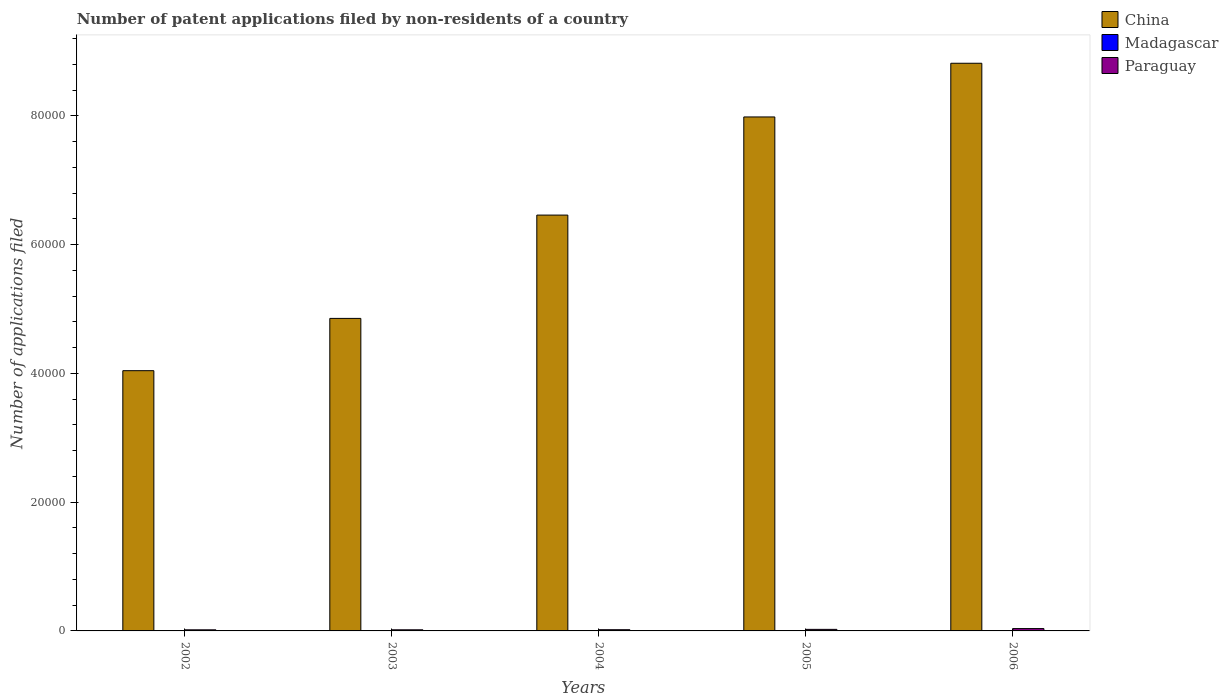How many different coloured bars are there?
Keep it short and to the point. 3. How many groups of bars are there?
Your answer should be compact. 5. Are the number of bars on each tick of the X-axis equal?
Your answer should be very brief. Yes. What is the number of applications filed in Madagascar in 2004?
Give a very brief answer. 22. Across all years, what is the minimum number of applications filed in Madagascar?
Provide a short and direct response. 20. What is the total number of applications filed in China in the graph?
Provide a succinct answer. 3.22e+05. What is the difference between the number of applications filed in Paraguay in 2002 and that in 2006?
Make the answer very short. -193. What is the difference between the number of applications filed in China in 2005 and the number of applications filed in Madagascar in 2006?
Your answer should be compact. 7.98e+04. What is the average number of applications filed in China per year?
Your response must be concise. 6.43e+04. In the year 2004, what is the difference between the number of applications filed in China and number of applications filed in Madagascar?
Provide a succinct answer. 6.46e+04. What is the ratio of the number of applications filed in Madagascar in 2003 to that in 2005?
Offer a very short reply. 0.57. Is the difference between the number of applications filed in China in 2002 and 2005 greater than the difference between the number of applications filed in Madagascar in 2002 and 2005?
Your answer should be very brief. No. What is the difference between the highest and the second highest number of applications filed in Paraguay?
Your answer should be compact. 123. What is the difference between the highest and the lowest number of applications filed in Paraguay?
Keep it short and to the point. 193. In how many years, is the number of applications filed in China greater than the average number of applications filed in China taken over all years?
Ensure brevity in your answer.  3. What does the 3rd bar from the left in 2005 represents?
Offer a very short reply. Paraguay. What does the 1st bar from the right in 2005 represents?
Offer a terse response. Paraguay. Is it the case that in every year, the sum of the number of applications filed in Paraguay and number of applications filed in China is greater than the number of applications filed in Madagascar?
Your response must be concise. Yes. How many bars are there?
Ensure brevity in your answer.  15. Does the graph contain any zero values?
Ensure brevity in your answer.  No. Where does the legend appear in the graph?
Ensure brevity in your answer.  Top right. How many legend labels are there?
Give a very brief answer. 3. What is the title of the graph?
Your answer should be very brief. Number of patent applications filed by non-residents of a country. Does "High income: OECD" appear as one of the legend labels in the graph?
Provide a succinct answer. No. What is the label or title of the X-axis?
Ensure brevity in your answer.  Years. What is the label or title of the Y-axis?
Keep it short and to the point. Number of applications filed. What is the Number of applications filed in China in 2002?
Give a very brief answer. 4.04e+04. What is the Number of applications filed of Madagascar in 2002?
Provide a succinct answer. 25. What is the Number of applications filed of Paraguay in 2002?
Keep it short and to the point. 171. What is the Number of applications filed of China in 2003?
Offer a very short reply. 4.85e+04. What is the Number of applications filed of Paraguay in 2003?
Your answer should be compact. 173. What is the Number of applications filed in China in 2004?
Your answer should be very brief. 6.46e+04. What is the Number of applications filed of Madagascar in 2004?
Offer a terse response. 22. What is the Number of applications filed of Paraguay in 2004?
Ensure brevity in your answer.  187. What is the Number of applications filed of China in 2005?
Offer a terse response. 7.98e+04. What is the Number of applications filed of Madagascar in 2005?
Your answer should be compact. 35. What is the Number of applications filed in Paraguay in 2005?
Provide a succinct answer. 241. What is the Number of applications filed in China in 2006?
Provide a succinct answer. 8.82e+04. What is the Number of applications filed in Madagascar in 2006?
Your response must be concise. 40. What is the Number of applications filed in Paraguay in 2006?
Make the answer very short. 364. Across all years, what is the maximum Number of applications filed in China?
Give a very brief answer. 8.82e+04. Across all years, what is the maximum Number of applications filed of Madagascar?
Your answer should be very brief. 40. Across all years, what is the maximum Number of applications filed in Paraguay?
Ensure brevity in your answer.  364. Across all years, what is the minimum Number of applications filed in China?
Offer a very short reply. 4.04e+04. Across all years, what is the minimum Number of applications filed in Paraguay?
Offer a very short reply. 171. What is the total Number of applications filed of China in the graph?
Keep it short and to the point. 3.22e+05. What is the total Number of applications filed of Madagascar in the graph?
Your answer should be very brief. 142. What is the total Number of applications filed in Paraguay in the graph?
Offer a terse response. 1136. What is the difference between the Number of applications filed of China in 2002 and that in 2003?
Your answer should be compact. -8122. What is the difference between the Number of applications filed in China in 2002 and that in 2004?
Give a very brief answer. -2.42e+04. What is the difference between the Number of applications filed of China in 2002 and that in 2005?
Offer a terse response. -3.94e+04. What is the difference between the Number of applications filed in Paraguay in 2002 and that in 2005?
Provide a succinct answer. -70. What is the difference between the Number of applications filed in China in 2002 and that in 2006?
Ensure brevity in your answer.  -4.78e+04. What is the difference between the Number of applications filed in Madagascar in 2002 and that in 2006?
Your response must be concise. -15. What is the difference between the Number of applications filed of Paraguay in 2002 and that in 2006?
Your answer should be compact. -193. What is the difference between the Number of applications filed in China in 2003 and that in 2004?
Your answer should be very brief. -1.60e+04. What is the difference between the Number of applications filed in China in 2003 and that in 2005?
Your response must be concise. -3.13e+04. What is the difference between the Number of applications filed in Paraguay in 2003 and that in 2005?
Your answer should be very brief. -68. What is the difference between the Number of applications filed of China in 2003 and that in 2006?
Your answer should be compact. -3.96e+04. What is the difference between the Number of applications filed in Madagascar in 2003 and that in 2006?
Offer a very short reply. -20. What is the difference between the Number of applications filed of Paraguay in 2003 and that in 2006?
Provide a succinct answer. -191. What is the difference between the Number of applications filed of China in 2004 and that in 2005?
Your answer should be very brief. -1.52e+04. What is the difference between the Number of applications filed in Paraguay in 2004 and that in 2005?
Make the answer very short. -54. What is the difference between the Number of applications filed of China in 2004 and that in 2006?
Make the answer very short. -2.36e+04. What is the difference between the Number of applications filed of Madagascar in 2004 and that in 2006?
Provide a succinct answer. -18. What is the difference between the Number of applications filed of Paraguay in 2004 and that in 2006?
Provide a short and direct response. -177. What is the difference between the Number of applications filed of China in 2005 and that in 2006?
Ensure brevity in your answer.  -8341. What is the difference between the Number of applications filed of Madagascar in 2005 and that in 2006?
Make the answer very short. -5. What is the difference between the Number of applications filed of Paraguay in 2005 and that in 2006?
Ensure brevity in your answer.  -123. What is the difference between the Number of applications filed in China in 2002 and the Number of applications filed in Madagascar in 2003?
Your answer should be very brief. 4.04e+04. What is the difference between the Number of applications filed in China in 2002 and the Number of applications filed in Paraguay in 2003?
Your answer should be very brief. 4.03e+04. What is the difference between the Number of applications filed of Madagascar in 2002 and the Number of applications filed of Paraguay in 2003?
Your answer should be compact. -148. What is the difference between the Number of applications filed in China in 2002 and the Number of applications filed in Madagascar in 2004?
Ensure brevity in your answer.  4.04e+04. What is the difference between the Number of applications filed of China in 2002 and the Number of applications filed of Paraguay in 2004?
Make the answer very short. 4.02e+04. What is the difference between the Number of applications filed of Madagascar in 2002 and the Number of applications filed of Paraguay in 2004?
Provide a succinct answer. -162. What is the difference between the Number of applications filed of China in 2002 and the Number of applications filed of Madagascar in 2005?
Offer a terse response. 4.04e+04. What is the difference between the Number of applications filed of China in 2002 and the Number of applications filed of Paraguay in 2005?
Ensure brevity in your answer.  4.02e+04. What is the difference between the Number of applications filed of Madagascar in 2002 and the Number of applications filed of Paraguay in 2005?
Provide a succinct answer. -216. What is the difference between the Number of applications filed of China in 2002 and the Number of applications filed of Madagascar in 2006?
Make the answer very short. 4.04e+04. What is the difference between the Number of applications filed in China in 2002 and the Number of applications filed in Paraguay in 2006?
Offer a terse response. 4.01e+04. What is the difference between the Number of applications filed in Madagascar in 2002 and the Number of applications filed in Paraguay in 2006?
Your answer should be compact. -339. What is the difference between the Number of applications filed in China in 2003 and the Number of applications filed in Madagascar in 2004?
Your response must be concise. 4.85e+04. What is the difference between the Number of applications filed of China in 2003 and the Number of applications filed of Paraguay in 2004?
Your answer should be very brief. 4.84e+04. What is the difference between the Number of applications filed of Madagascar in 2003 and the Number of applications filed of Paraguay in 2004?
Keep it short and to the point. -167. What is the difference between the Number of applications filed of China in 2003 and the Number of applications filed of Madagascar in 2005?
Ensure brevity in your answer.  4.85e+04. What is the difference between the Number of applications filed of China in 2003 and the Number of applications filed of Paraguay in 2005?
Keep it short and to the point. 4.83e+04. What is the difference between the Number of applications filed of Madagascar in 2003 and the Number of applications filed of Paraguay in 2005?
Make the answer very short. -221. What is the difference between the Number of applications filed of China in 2003 and the Number of applications filed of Madagascar in 2006?
Provide a succinct answer. 4.85e+04. What is the difference between the Number of applications filed in China in 2003 and the Number of applications filed in Paraguay in 2006?
Give a very brief answer. 4.82e+04. What is the difference between the Number of applications filed of Madagascar in 2003 and the Number of applications filed of Paraguay in 2006?
Ensure brevity in your answer.  -344. What is the difference between the Number of applications filed of China in 2004 and the Number of applications filed of Madagascar in 2005?
Ensure brevity in your answer.  6.46e+04. What is the difference between the Number of applications filed in China in 2004 and the Number of applications filed in Paraguay in 2005?
Keep it short and to the point. 6.44e+04. What is the difference between the Number of applications filed of Madagascar in 2004 and the Number of applications filed of Paraguay in 2005?
Make the answer very short. -219. What is the difference between the Number of applications filed in China in 2004 and the Number of applications filed in Madagascar in 2006?
Keep it short and to the point. 6.46e+04. What is the difference between the Number of applications filed of China in 2004 and the Number of applications filed of Paraguay in 2006?
Offer a very short reply. 6.42e+04. What is the difference between the Number of applications filed in Madagascar in 2004 and the Number of applications filed in Paraguay in 2006?
Give a very brief answer. -342. What is the difference between the Number of applications filed in China in 2005 and the Number of applications filed in Madagascar in 2006?
Your answer should be very brief. 7.98e+04. What is the difference between the Number of applications filed of China in 2005 and the Number of applications filed of Paraguay in 2006?
Provide a succinct answer. 7.95e+04. What is the difference between the Number of applications filed of Madagascar in 2005 and the Number of applications filed of Paraguay in 2006?
Keep it short and to the point. -329. What is the average Number of applications filed of China per year?
Provide a short and direct response. 6.43e+04. What is the average Number of applications filed in Madagascar per year?
Ensure brevity in your answer.  28.4. What is the average Number of applications filed of Paraguay per year?
Offer a very short reply. 227.2. In the year 2002, what is the difference between the Number of applications filed in China and Number of applications filed in Madagascar?
Your response must be concise. 4.04e+04. In the year 2002, what is the difference between the Number of applications filed in China and Number of applications filed in Paraguay?
Ensure brevity in your answer.  4.03e+04. In the year 2002, what is the difference between the Number of applications filed in Madagascar and Number of applications filed in Paraguay?
Offer a terse response. -146. In the year 2003, what is the difference between the Number of applications filed of China and Number of applications filed of Madagascar?
Ensure brevity in your answer.  4.85e+04. In the year 2003, what is the difference between the Number of applications filed in China and Number of applications filed in Paraguay?
Make the answer very short. 4.84e+04. In the year 2003, what is the difference between the Number of applications filed of Madagascar and Number of applications filed of Paraguay?
Offer a very short reply. -153. In the year 2004, what is the difference between the Number of applications filed of China and Number of applications filed of Madagascar?
Your response must be concise. 6.46e+04. In the year 2004, what is the difference between the Number of applications filed in China and Number of applications filed in Paraguay?
Offer a very short reply. 6.44e+04. In the year 2004, what is the difference between the Number of applications filed in Madagascar and Number of applications filed in Paraguay?
Ensure brevity in your answer.  -165. In the year 2005, what is the difference between the Number of applications filed in China and Number of applications filed in Madagascar?
Make the answer very short. 7.98e+04. In the year 2005, what is the difference between the Number of applications filed in China and Number of applications filed in Paraguay?
Offer a terse response. 7.96e+04. In the year 2005, what is the difference between the Number of applications filed of Madagascar and Number of applications filed of Paraguay?
Make the answer very short. -206. In the year 2006, what is the difference between the Number of applications filed of China and Number of applications filed of Madagascar?
Make the answer very short. 8.81e+04. In the year 2006, what is the difference between the Number of applications filed of China and Number of applications filed of Paraguay?
Offer a very short reply. 8.78e+04. In the year 2006, what is the difference between the Number of applications filed of Madagascar and Number of applications filed of Paraguay?
Your response must be concise. -324. What is the ratio of the Number of applications filed in China in 2002 to that in 2003?
Give a very brief answer. 0.83. What is the ratio of the Number of applications filed of Paraguay in 2002 to that in 2003?
Your response must be concise. 0.99. What is the ratio of the Number of applications filed of China in 2002 to that in 2004?
Give a very brief answer. 0.63. What is the ratio of the Number of applications filed in Madagascar in 2002 to that in 2004?
Your answer should be very brief. 1.14. What is the ratio of the Number of applications filed of Paraguay in 2002 to that in 2004?
Your response must be concise. 0.91. What is the ratio of the Number of applications filed in China in 2002 to that in 2005?
Your answer should be very brief. 0.51. What is the ratio of the Number of applications filed of Paraguay in 2002 to that in 2005?
Offer a terse response. 0.71. What is the ratio of the Number of applications filed of China in 2002 to that in 2006?
Provide a short and direct response. 0.46. What is the ratio of the Number of applications filed in Madagascar in 2002 to that in 2006?
Your answer should be compact. 0.62. What is the ratio of the Number of applications filed in Paraguay in 2002 to that in 2006?
Your answer should be compact. 0.47. What is the ratio of the Number of applications filed in China in 2003 to that in 2004?
Your response must be concise. 0.75. What is the ratio of the Number of applications filed of Paraguay in 2003 to that in 2004?
Ensure brevity in your answer.  0.93. What is the ratio of the Number of applications filed of China in 2003 to that in 2005?
Give a very brief answer. 0.61. What is the ratio of the Number of applications filed in Madagascar in 2003 to that in 2005?
Provide a succinct answer. 0.57. What is the ratio of the Number of applications filed of Paraguay in 2003 to that in 2005?
Give a very brief answer. 0.72. What is the ratio of the Number of applications filed in China in 2003 to that in 2006?
Provide a short and direct response. 0.55. What is the ratio of the Number of applications filed in Paraguay in 2003 to that in 2006?
Keep it short and to the point. 0.48. What is the ratio of the Number of applications filed in China in 2004 to that in 2005?
Your answer should be compact. 0.81. What is the ratio of the Number of applications filed of Madagascar in 2004 to that in 2005?
Make the answer very short. 0.63. What is the ratio of the Number of applications filed in Paraguay in 2004 to that in 2005?
Provide a short and direct response. 0.78. What is the ratio of the Number of applications filed in China in 2004 to that in 2006?
Ensure brevity in your answer.  0.73. What is the ratio of the Number of applications filed of Madagascar in 2004 to that in 2006?
Provide a short and direct response. 0.55. What is the ratio of the Number of applications filed of Paraguay in 2004 to that in 2006?
Provide a succinct answer. 0.51. What is the ratio of the Number of applications filed in China in 2005 to that in 2006?
Your answer should be very brief. 0.91. What is the ratio of the Number of applications filed in Madagascar in 2005 to that in 2006?
Provide a succinct answer. 0.88. What is the ratio of the Number of applications filed of Paraguay in 2005 to that in 2006?
Give a very brief answer. 0.66. What is the difference between the highest and the second highest Number of applications filed of China?
Provide a succinct answer. 8341. What is the difference between the highest and the second highest Number of applications filed in Paraguay?
Your answer should be very brief. 123. What is the difference between the highest and the lowest Number of applications filed in China?
Provide a short and direct response. 4.78e+04. What is the difference between the highest and the lowest Number of applications filed of Madagascar?
Your answer should be compact. 20. What is the difference between the highest and the lowest Number of applications filed in Paraguay?
Your answer should be compact. 193. 